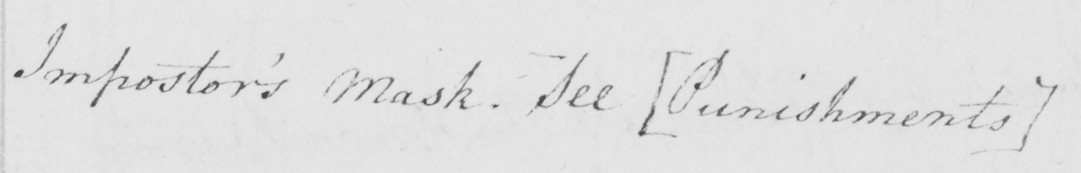Please provide the text content of this handwritten line. Impostor ' s Mask . See  [ Punishments ] 